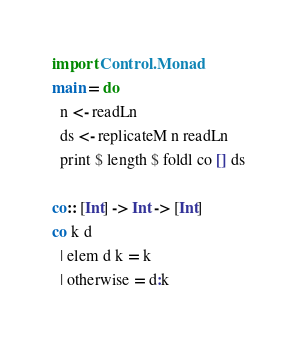Convert code to text. <code><loc_0><loc_0><loc_500><loc_500><_Haskell_>import Control.Monad
main = do
  n <- readLn
  ds <- replicateM n readLn
  print $ length $ foldl co [] ds

co:: [Int] -> Int -> [Int]
co k d
  | elem d k = k
  | otherwise = d:k
</code> 